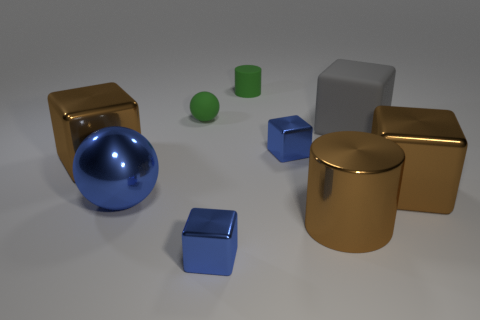Subtract all green cylinders. How many blue blocks are left? 2 Subtract all blue blocks. How many blocks are left? 3 Subtract all brown cubes. How many cubes are left? 3 Add 1 brown metal cylinders. How many objects exist? 10 Subtract all spheres. How many objects are left? 7 Subtract all yellow blocks. Subtract all yellow cylinders. How many blocks are left? 5 Add 5 metallic cylinders. How many metallic cylinders exist? 6 Subtract 1 blue cubes. How many objects are left? 8 Subtract all metal spheres. Subtract all matte things. How many objects are left? 5 Add 2 big gray objects. How many big gray objects are left? 3 